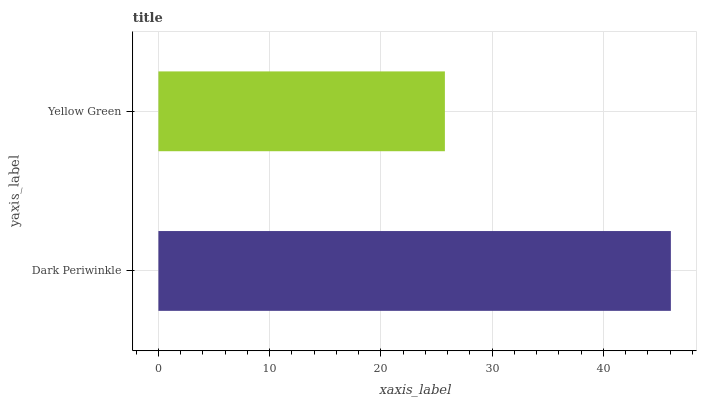Is Yellow Green the minimum?
Answer yes or no. Yes. Is Dark Periwinkle the maximum?
Answer yes or no. Yes. Is Yellow Green the maximum?
Answer yes or no. No. Is Dark Periwinkle greater than Yellow Green?
Answer yes or no. Yes. Is Yellow Green less than Dark Periwinkle?
Answer yes or no. Yes. Is Yellow Green greater than Dark Periwinkle?
Answer yes or no. No. Is Dark Periwinkle less than Yellow Green?
Answer yes or no. No. Is Dark Periwinkle the high median?
Answer yes or no. Yes. Is Yellow Green the low median?
Answer yes or no. Yes. Is Yellow Green the high median?
Answer yes or no. No. Is Dark Periwinkle the low median?
Answer yes or no. No. 